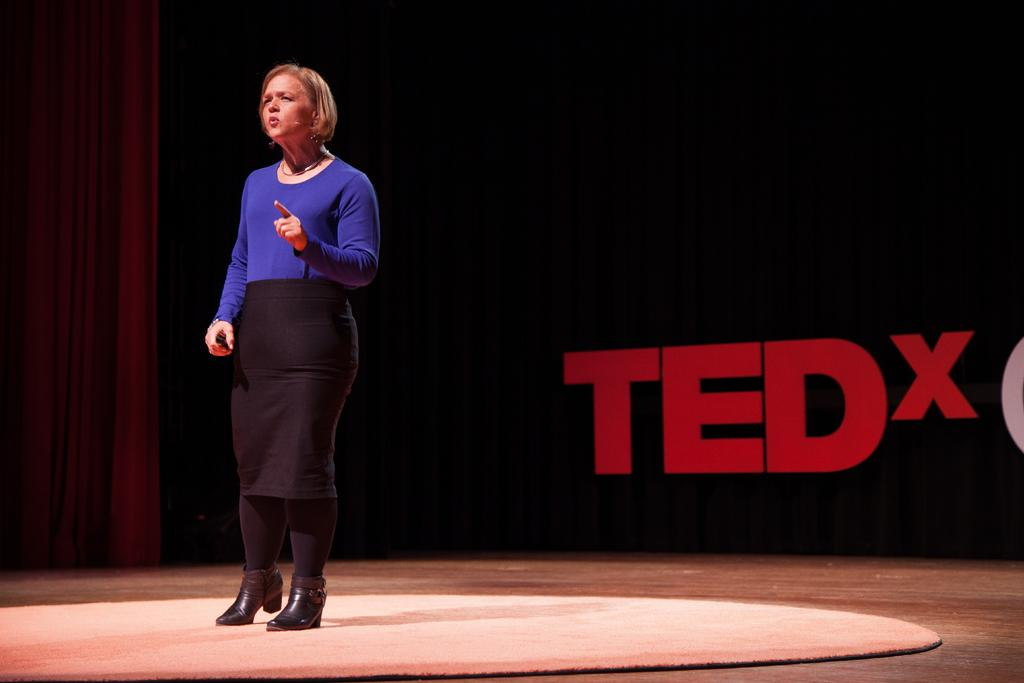What is the main subject of the image? There is a woman standing in the image. What is the woman doing in the image? The woman is talking. How would you describe the background of the image? The background of the image is dark. Can you identify any specific objects or features in the background? Yes, there is a curtain and some text visible in the background of the image. What type of dress is the woman wearing in the image? The provided facts do not mention the type of dress the woman is wearing, so we cannot answer this question definitively. What is the woman drinking in the image? There is no indication in the image that the woman is drinking anything, so we cannot answer this question definitively. 